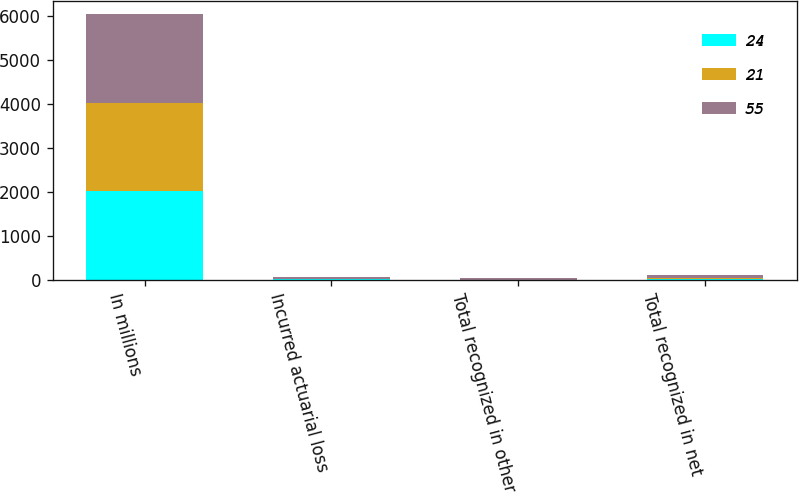Convert chart. <chart><loc_0><loc_0><loc_500><loc_500><stacked_bar_chart><ecel><fcel>In millions<fcel>Incurred actuarial loss<fcel>Total recognized in other<fcel>Total recognized in net<nl><fcel>24<fcel>2016<fcel>9<fcel>3<fcel>24<nl><fcel>21<fcel>2015<fcel>6<fcel>1<fcel>21<nl><fcel>55<fcel>2014<fcel>38<fcel>38<fcel>55<nl></chart> 